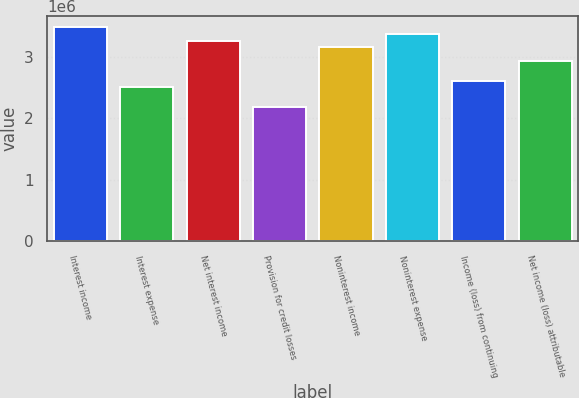<chart> <loc_0><loc_0><loc_500><loc_500><bar_chart><fcel>Interest income<fcel>Interest expense<fcel>Net interest income<fcel>Provision for credit losses<fcel>Noninterest income<fcel>Noninterest expense<fcel>Income (loss) from continuing<fcel>Net income (loss) attributable<nl><fcel>3.48429e+06<fcel>2.50433e+06<fcel>3.26652e+06<fcel>2.17768e+06<fcel>3.15764e+06<fcel>3.37541e+06<fcel>2.61322e+06<fcel>2.93987e+06<nl></chart> 